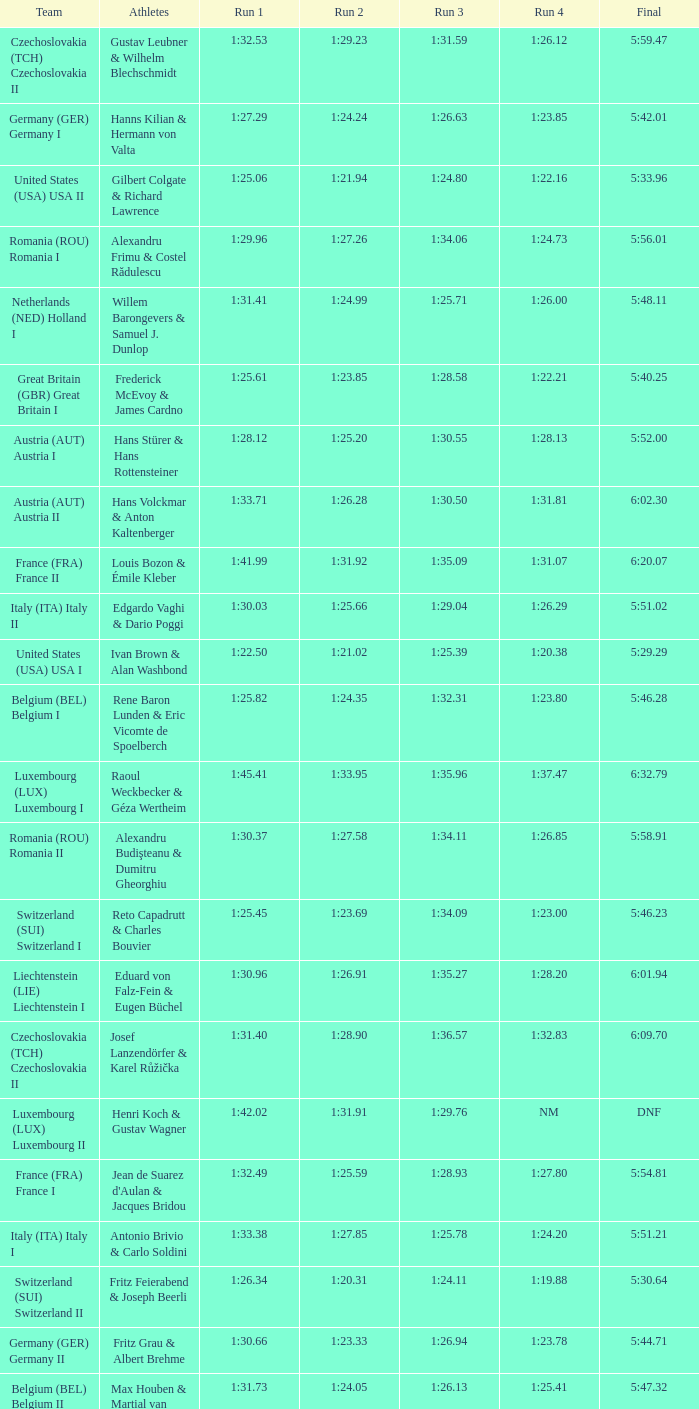Which Run 4 has a Run 1 of 1:25.82? 1:23.80. 